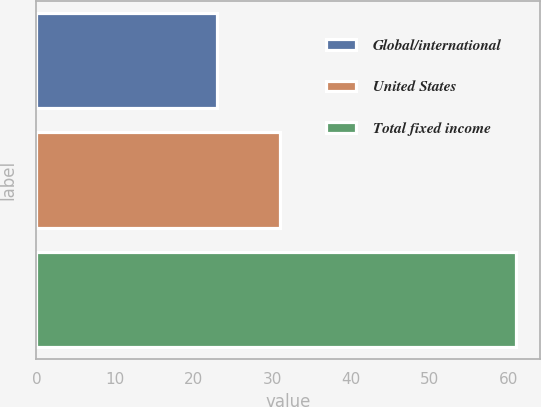Convert chart. <chart><loc_0><loc_0><loc_500><loc_500><bar_chart><fcel>Global/international<fcel>United States<fcel>Total fixed income<nl><fcel>23<fcel>31<fcel>61<nl></chart> 